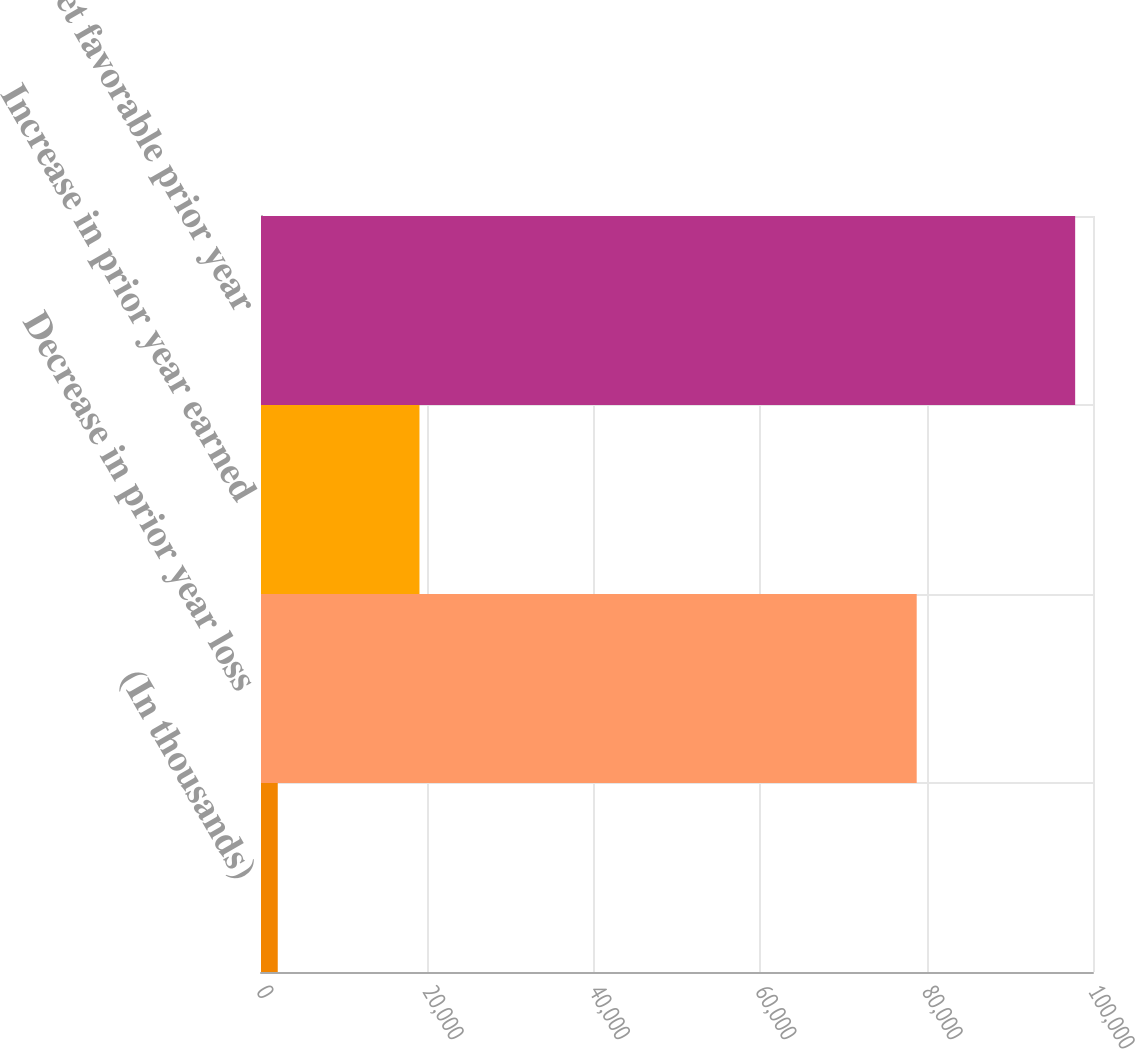<chart> <loc_0><loc_0><loc_500><loc_500><bar_chart><fcel>(In thousands)<fcel>Decrease in prior year loss<fcel>Increase in prior year earned<fcel>Net favorable prior year<nl><fcel>2013<fcel>78810<fcel>19046<fcel>97856<nl></chart> 